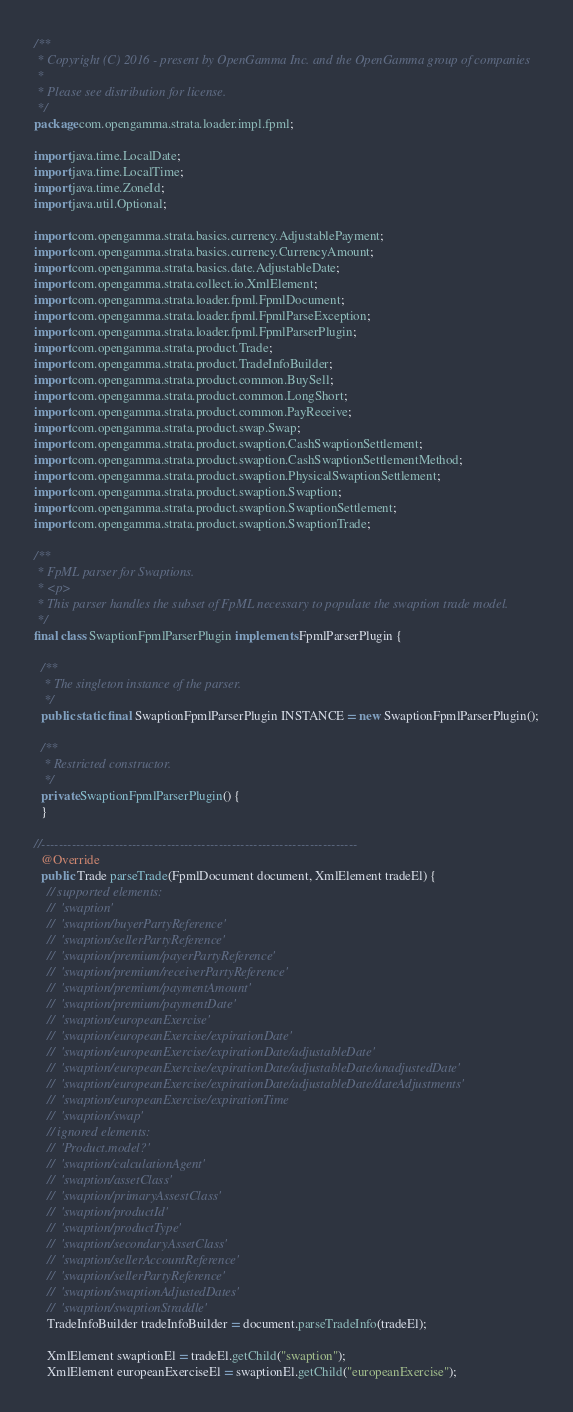<code> <loc_0><loc_0><loc_500><loc_500><_Java_>/**
 * Copyright (C) 2016 - present by OpenGamma Inc. and the OpenGamma group of companies
 *
 * Please see distribution for license.
 */
package com.opengamma.strata.loader.impl.fpml;

import java.time.LocalDate;
import java.time.LocalTime;
import java.time.ZoneId;
import java.util.Optional;

import com.opengamma.strata.basics.currency.AdjustablePayment;
import com.opengamma.strata.basics.currency.CurrencyAmount;
import com.opengamma.strata.basics.date.AdjustableDate;
import com.opengamma.strata.collect.io.XmlElement;
import com.opengamma.strata.loader.fpml.FpmlDocument;
import com.opengamma.strata.loader.fpml.FpmlParseException;
import com.opengamma.strata.loader.fpml.FpmlParserPlugin;
import com.opengamma.strata.product.Trade;
import com.opengamma.strata.product.TradeInfoBuilder;
import com.opengamma.strata.product.common.BuySell;
import com.opengamma.strata.product.common.LongShort;
import com.opengamma.strata.product.common.PayReceive;
import com.opengamma.strata.product.swap.Swap;
import com.opengamma.strata.product.swaption.CashSwaptionSettlement;
import com.opengamma.strata.product.swaption.CashSwaptionSettlementMethod;
import com.opengamma.strata.product.swaption.PhysicalSwaptionSettlement;
import com.opengamma.strata.product.swaption.Swaption;
import com.opengamma.strata.product.swaption.SwaptionSettlement;
import com.opengamma.strata.product.swaption.SwaptionTrade;

/**
 * FpML parser for Swaptions.
 * <p>
 * This parser handles the subset of FpML necessary to populate the swaption trade model.
 */
final class SwaptionFpmlParserPlugin implements FpmlParserPlugin {

  /**
   * The singleton instance of the parser.
   */
  public static final SwaptionFpmlParserPlugin INSTANCE = new SwaptionFpmlParserPlugin();

  /**
   * Restricted constructor.
   */
  private SwaptionFpmlParserPlugin() {
  }

//-------------------------------------------------------------------------
  @Override
  public Trade parseTrade(FpmlDocument document, XmlElement tradeEl) {
    // supported elements:
    //  'swaption'
    //  'swaption/buyerPartyReference'
    //  'swaption/sellerPartyReference'
    //  'swaption/premium/payerPartyReference'
    //  'swaption/premium/receiverPartyReference'
    //  'swaption/premium/paymentAmount'
    //  'swaption/premium/paymentDate'
    //  'swaption/europeanExercise'
    //  'swaption/europeanExercise/expirationDate'
    //  'swaption/europeanExercise/expirationDate/adjustableDate'
    //  'swaption/europeanExercise/expirationDate/adjustableDate/unadjustedDate'
    //  'swaption/europeanExercise/expirationDate/adjustableDate/dateAdjustments'
    //  'swaption/europeanExercise/expirationTime
    //  'swaption/swap'
    // ignored elements:
    //  'Product.model?'
    //  'swaption/calculationAgent'
    //  'swaption/assetClass'
    //  'swaption/primaryAssestClass'
    //  'swaption/productId'
    //  'swaption/productType'
    //  'swaption/secondaryAssetClass'
    //  'swaption/sellerAccountReference'
    //  'swaption/sellerPartyReference'
    //  'swaption/swaptionAdjustedDates'
    //  'swaption/swaptionStraddle'
    TradeInfoBuilder tradeInfoBuilder = document.parseTradeInfo(tradeEl);

    XmlElement swaptionEl = tradeEl.getChild("swaption");
    XmlElement europeanExerciseEl = swaptionEl.getChild("europeanExercise");</code> 